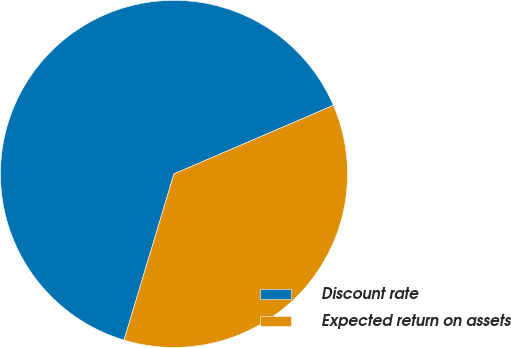<chart> <loc_0><loc_0><loc_500><loc_500><pie_chart><fcel>Discount rate<fcel>Expected return on assets<nl><fcel>63.89%<fcel>36.11%<nl></chart> 